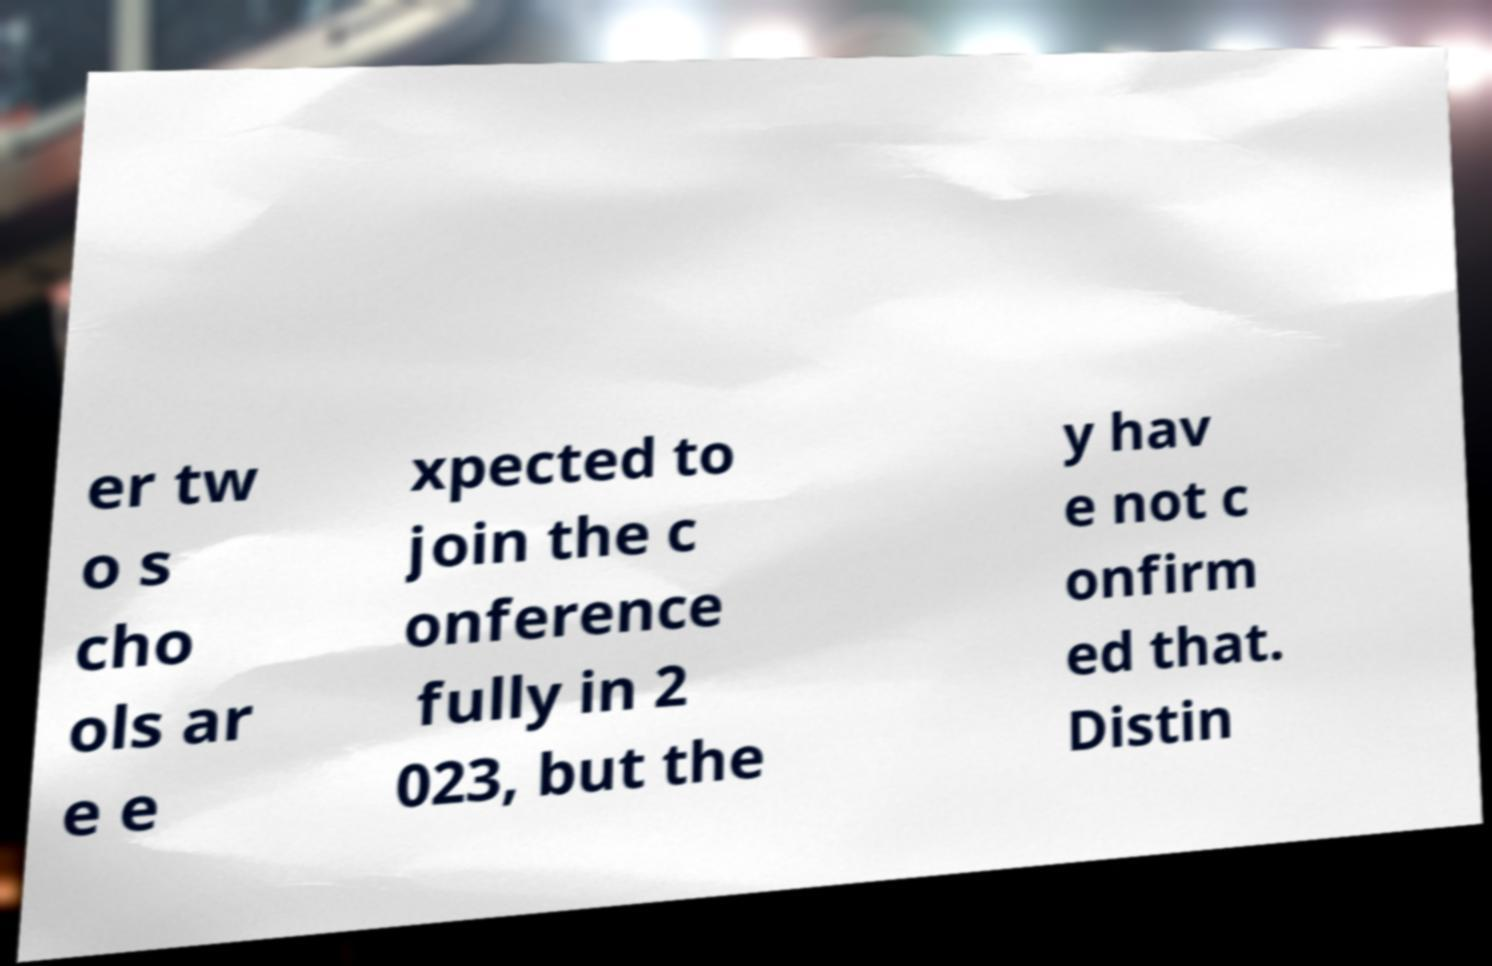Please read and relay the text visible in this image. What does it say? er tw o s cho ols ar e e xpected to join the c onference fully in 2 023, but the y hav e not c onfirm ed that. Distin 